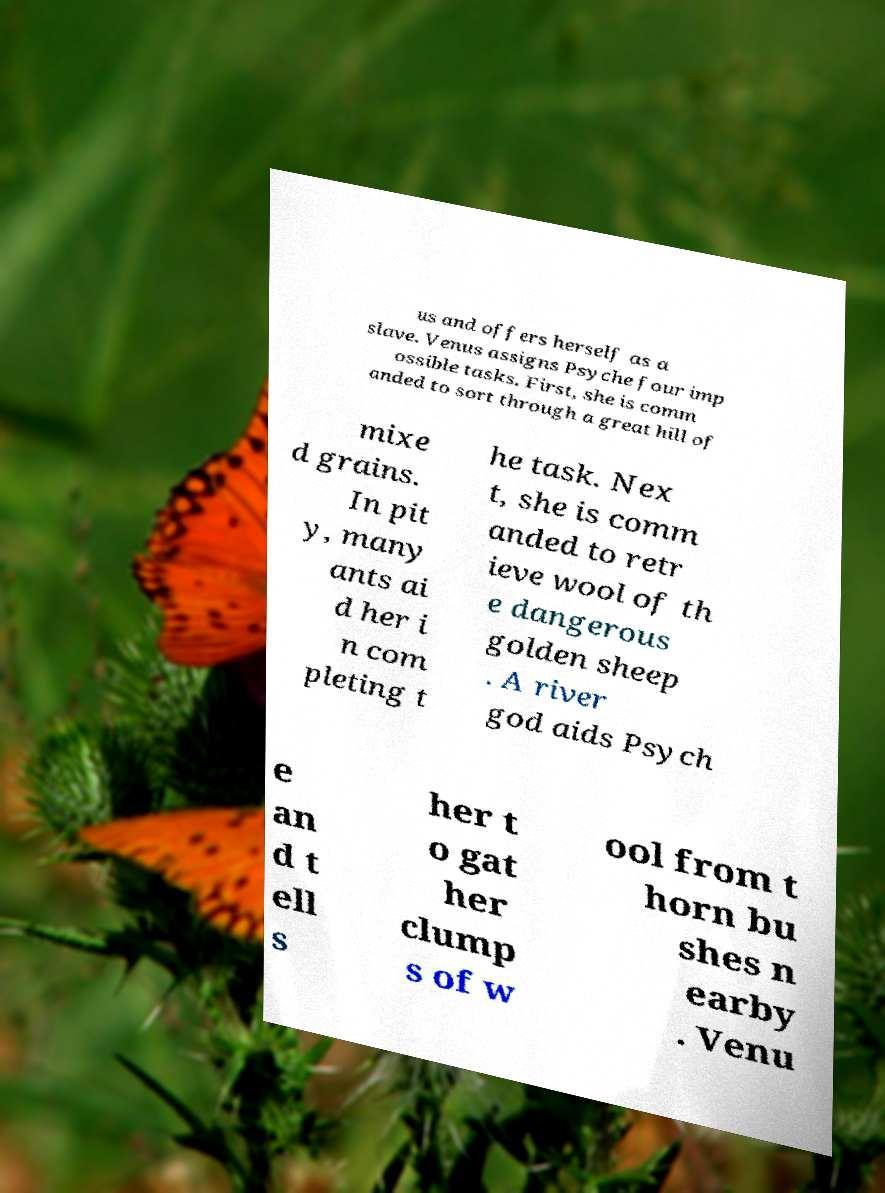Can you read and provide the text displayed in the image?This photo seems to have some interesting text. Can you extract and type it out for me? us and offers herself as a slave. Venus assigns Psyche four imp ossible tasks. First, she is comm anded to sort through a great hill of mixe d grains. In pit y, many ants ai d her i n com pleting t he task. Nex t, she is comm anded to retr ieve wool of th e dangerous golden sheep . A river god aids Psych e an d t ell s her t o gat her clump s of w ool from t horn bu shes n earby . Venu 